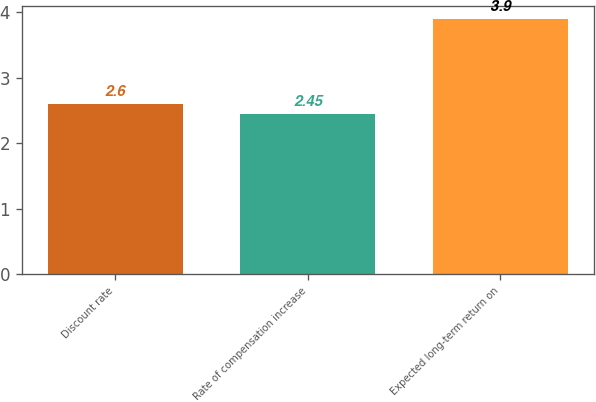Convert chart. <chart><loc_0><loc_0><loc_500><loc_500><bar_chart><fcel>Discount rate<fcel>Rate of compensation increase<fcel>Expected long-term return on<nl><fcel>2.6<fcel>2.45<fcel>3.9<nl></chart> 